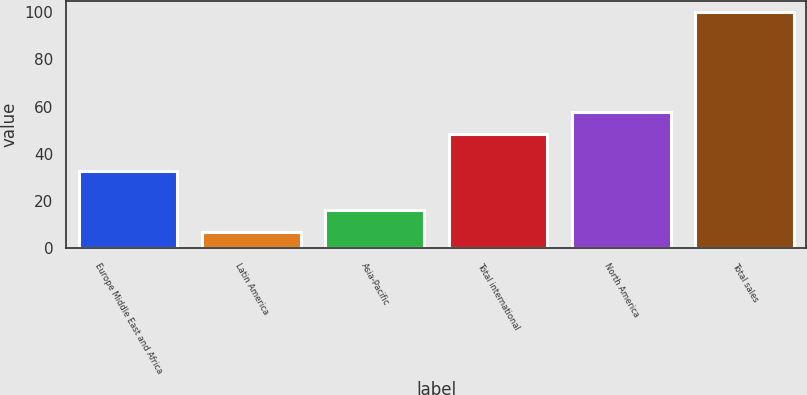Convert chart to OTSL. <chart><loc_0><loc_0><loc_500><loc_500><bar_chart><fcel>Europe Middle East and Africa<fcel>Latin America<fcel>Asia-Pacific<fcel>Total international<fcel>North America<fcel>Total sales<nl><fcel>32.8<fcel>6.7<fcel>16.03<fcel>48.5<fcel>57.83<fcel>100<nl></chart> 